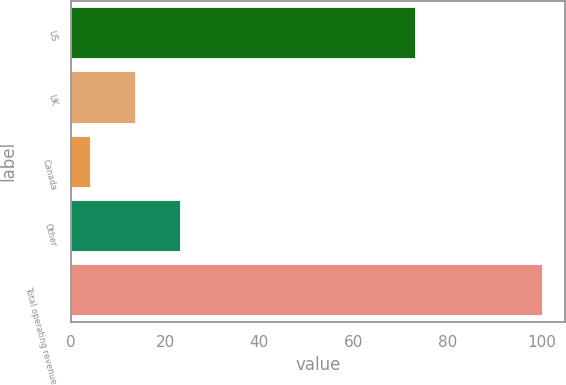Convert chart to OTSL. <chart><loc_0><loc_0><loc_500><loc_500><bar_chart><fcel>US<fcel>UK<fcel>Canada<fcel>Other<fcel>Total operating revenue<nl><fcel>73<fcel>13.6<fcel>4<fcel>23.2<fcel>100<nl></chart> 